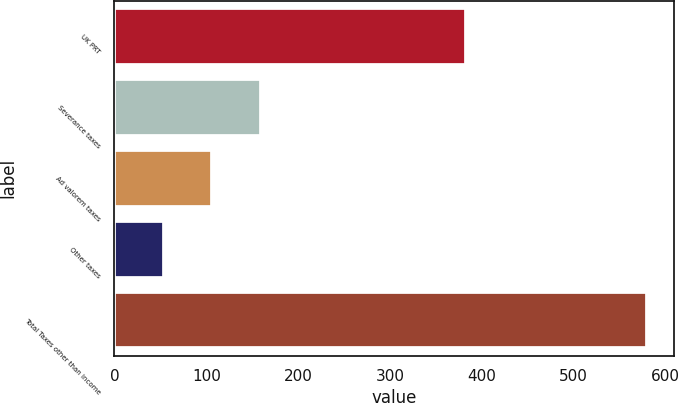Convert chart to OTSL. <chart><loc_0><loc_0><loc_500><loc_500><bar_chart><fcel>UK PRT<fcel>Severance taxes<fcel>Ad valorem taxes<fcel>Other taxes<fcel>Total Taxes other than income<nl><fcel>383<fcel>159.2<fcel>106.6<fcel>54<fcel>580<nl></chart> 